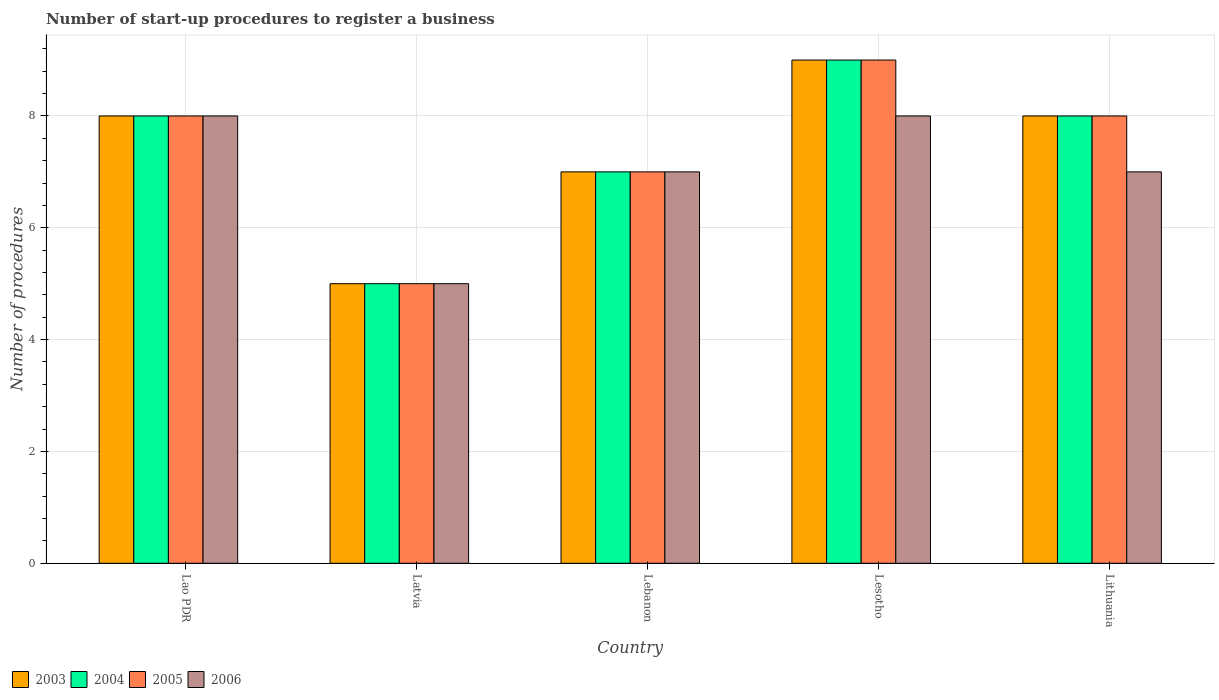How many groups of bars are there?
Offer a very short reply. 5. Are the number of bars on each tick of the X-axis equal?
Offer a terse response. Yes. How many bars are there on the 2nd tick from the left?
Give a very brief answer. 4. How many bars are there on the 4th tick from the right?
Make the answer very short. 4. What is the label of the 1st group of bars from the left?
Give a very brief answer. Lao PDR. In how many cases, is the number of bars for a given country not equal to the number of legend labels?
Make the answer very short. 0. Across all countries, what is the maximum number of procedures required to register a business in 2006?
Provide a succinct answer. 8. In which country was the number of procedures required to register a business in 2003 maximum?
Offer a terse response. Lesotho. In which country was the number of procedures required to register a business in 2004 minimum?
Ensure brevity in your answer.  Latvia. What is the difference between the number of procedures required to register a business in 2005 in Lebanon and that in Lesotho?
Make the answer very short. -2. What is the difference between the number of procedures required to register a business in 2003 in Lao PDR and the number of procedures required to register a business in 2004 in Lebanon?
Give a very brief answer. 1. In how many countries, is the number of procedures required to register a business in 2003 greater than 6?
Keep it short and to the point. 4. What is the ratio of the number of procedures required to register a business in 2006 in Lao PDR to that in Lithuania?
Offer a very short reply. 1.14. What is the difference between the highest and the second highest number of procedures required to register a business in 2003?
Give a very brief answer. -1. In how many countries, is the number of procedures required to register a business in 2005 greater than the average number of procedures required to register a business in 2005 taken over all countries?
Keep it short and to the point. 3. Is the sum of the number of procedures required to register a business in 2003 in Lao PDR and Latvia greater than the maximum number of procedures required to register a business in 2004 across all countries?
Give a very brief answer. Yes. Is it the case that in every country, the sum of the number of procedures required to register a business in 2004 and number of procedures required to register a business in 2006 is greater than the sum of number of procedures required to register a business in 2003 and number of procedures required to register a business in 2005?
Give a very brief answer. No. What does the 3rd bar from the left in Lao PDR represents?
Your response must be concise. 2005. How many countries are there in the graph?
Give a very brief answer. 5. Are the values on the major ticks of Y-axis written in scientific E-notation?
Offer a very short reply. No. Does the graph contain any zero values?
Offer a very short reply. No. How many legend labels are there?
Your response must be concise. 4. How are the legend labels stacked?
Keep it short and to the point. Horizontal. What is the title of the graph?
Offer a terse response. Number of start-up procedures to register a business. What is the label or title of the X-axis?
Your answer should be compact. Country. What is the label or title of the Y-axis?
Keep it short and to the point. Number of procedures. What is the Number of procedures in 2003 in Lao PDR?
Offer a terse response. 8. What is the Number of procedures in 2003 in Latvia?
Provide a short and direct response. 5. What is the Number of procedures of 2005 in Latvia?
Provide a succinct answer. 5. What is the Number of procedures in 2005 in Lebanon?
Your response must be concise. 7. What is the Number of procedures in 2006 in Lebanon?
Provide a short and direct response. 7. What is the Number of procedures of 2003 in Lesotho?
Offer a terse response. 9. What is the Number of procedures of 2004 in Lesotho?
Keep it short and to the point. 9. What is the Number of procedures in 2006 in Lesotho?
Offer a very short reply. 8. What is the Number of procedures of 2005 in Lithuania?
Provide a succinct answer. 8. What is the Number of procedures in 2006 in Lithuania?
Provide a short and direct response. 7. Across all countries, what is the maximum Number of procedures in 2003?
Your answer should be very brief. 9. Across all countries, what is the maximum Number of procedures in 2004?
Your response must be concise. 9. Across all countries, what is the maximum Number of procedures in 2006?
Provide a succinct answer. 8. Across all countries, what is the minimum Number of procedures in 2003?
Give a very brief answer. 5. What is the total Number of procedures in 2003 in the graph?
Your response must be concise. 37. What is the total Number of procedures of 2004 in the graph?
Offer a terse response. 37. What is the total Number of procedures in 2006 in the graph?
Give a very brief answer. 35. What is the difference between the Number of procedures of 2003 in Lao PDR and that in Latvia?
Your response must be concise. 3. What is the difference between the Number of procedures in 2004 in Lao PDR and that in Latvia?
Provide a succinct answer. 3. What is the difference between the Number of procedures in 2003 in Lao PDR and that in Lebanon?
Make the answer very short. 1. What is the difference between the Number of procedures in 2005 in Lao PDR and that in Lebanon?
Your answer should be compact. 1. What is the difference between the Number of procedures in 2006 in Lao PDR and that in Lebanon?
Your response must be concise. 1. What is the difference between the Number of procedures in 2004 in Lao PDR and that in Lesotho?
Your answer should be compact. -1. What is the difference between the Number of procedures in 2005 in Lao PDR and that in Lesotho?
Offer a terse response. -1. What is the difference between the Number of procedures of 2006 in Lao PDR and that in Lesotho?
Offer a terse response. 0. What is the difference between the Number of procedures in 2005 in Lao PDR and that in Lithuania?
Provide a succinct answer. 0. What is the difference between the Number of procedures in 2006 in Lao PDR and that in Lithuania?
Give a very brief answer. 1. What is the difference between the Number of procedures of 2003 in Latvia and that in Lebanon?
Offer a very short reply. -2. What is the difference between the Number of procedures in 2005 in Latvia and that in Lebanon?
Your answer should be very brief. -2. What is the difference between the Number of procedures in 2006 in Latvia and that in Lebanon?
Provide a succinct answer. -2. What is the difference between the Number of procedures of 2003 in Latvia and that in Lesotho?
Offer a terse response. -4. What is the difference between the Number of procedures in 2006 in Latvia and that in Lesotho?
Your answer should be compact. -3. What is the difference between the Number of procedures in 2004 in Latvia and that in Lithuania?
Keep it short and to the point. -3. What is the difference between the Number of procedures in 2005 in Latvia and that in Lithuania?
Offer a terse response. -3. What is the difference between the Number of procedures of 2006 in Latvia and that in Lithuania?
Ensure brevity in your answer.  -2. What is the difference between the Number of procedures in 2005 in Lebanon and that in Lesotho?
Keep it short and to the point. -2. What is the difference between the Number of procedures in 2006 in Lebanon and that in Lesotho?
Make the answer very short. -1. What is the difference between the Number of procedures in 2003 in Lebanon and that in Lithuania?
Your answer should be compact. -1. What is the difference between the Number of procedures of 2005 in Lebanon and that in Lithuania?
Your answer should be compact. -1. What is the difference between the Number of procedures of 2006 in Lebanon and that in Lithuania?
Offer a terse response. 0. What is the difference between the Number of procedures of 2003 in Lesotho and that in Lithuania?
Offer a very short reply. 1. What is the difference between the Number of procedures in 2006 in Lesotho and that in Lithuania?
Give a very brief answer. 1. What is the difference between the Number of procedures of 2003 in Lao PDR and the Number of procedures of 2005 in Latvia?
Give a very brief answer. 3. What is the difference between the Number of procedures in 2003 in Lao PDR and the Number of procedures in 2006 in Latvia?
Offer a terse response. 3. What is the difference between the Number of procedures of 2004 in Lao PDR and the Number of procedures of 2006 in Latvia?
Offer a terse response. 3. What is the difference between the Number of procedures in 2003 in Lao PDR and the Number of procedures in 2005 in Lebanon?
Give a very brief answer. 1. What is the difference between the Number of procedures in 2004 in Lao PDR and the Number of procedures in 2006 in Lebanon?
Give a very brief answer. 1. What is the difference between the Number of procedures of 2003 in Lao PDR and the Number of procedures of 2004 in Lesotho?
Make the answer very short. -1. What is the difference between the Number of procedures of 2003 in Lao PDR and the Number of procedures of 2006 in Lesotho?
Make the answer very short. 0. What is the difference between the Number of procedures in 2003 in Lao PDR and the Number of procedures in 2004 in Lithuania?
Provide a short and direct response. 0. What is the difference between the Number of procedures of 2003 in Lao PDR and the Number of procedures of 2006 in Lithuania?
Keep it short and to the point. 1. What is the difference between the Number of procedures in 2005 in Lao PDR and the Number of procedures in 2006 in Lithuania?
Offer a terse response. 1. What is the difference between the Number of procedures in 2003 in Latvia and the Number of procedures in 2004 in Lebanon?
Your answer should be very brief. -2. What is the difference between the Number of procedures in 2003 in Latvia and the Number of procedures in 2005 in Lebanon?
Provide a short and direct response. -2. What is the difference between the Number of procedures in 2003 in Latvia and the Number of procedures in 2006 in Lebanon?
Offer a terse response. -2. What is the difference between the Number of procedures of 2004 in Latvia and the Number of procedures of 2006 in Lebanon?
Make the answer very short. -2. What is the difference between the Number of procedures in 2005 in Latvia and the Number of procedures in 2006 in Lebanon?
Keep it short and to the point. -2. What is the difference between the Number of procedures in 2003 in Latvia and the Number of procedures in 2006 in Lesotho?
Ensure brevity in your answer.  -3. What is the difference between the Number of procedures of 2004 in Latvia and the Number of procedures of 2006 in Lesotho?
Ensure brevity in your answer.  -3. What is the difference between the Number of procedures of 2003 in Latvia and the Number of procedures of 2005 in Lithuania?
Give a very brief answer. -3. What is the difference between the Number of procedures in 2004 in Latvia and the Number of procedures in 2005 in Lithuania?
Offer a terse response. -3. What is the difference between the Number of procedures in 2003 in Lebanon and the Number of procedures in 2005 in Lesotho?
Ensure brevity in your answer.  -2. What is the difference between the Number of procedures of 2003 in Lebanon and the Number of procedures of 2006 in Lesotho?
Your answer should be compact. -1. What is the difference between the Number of procedures in 2004 in Lebanon and the Number of procedures in 2006 in Lesotho?
Provide a succinct answer. -1. What is the difference between the Number of procedures of 2005 in Lebanon and the Number of procedures of 2006 in Lesotho?
Your response must be concise. -1. What is the difference between the Number of procedures in 2003 in Lebanon and the Number of procedures in 2004 in Lithuania?
Offer a terse response. -1. What is the difference between the Number of procedures of 2004 in Lebanon and the Number of procedures of 2005 in Lithuania?
Ensure brevity in your answer.  -1. What is the difference between the Number of procedures in 2004 in Lebanon and the Number of procedures in 2006 in Lithuania?
Provide a short and direct response. 0. What is the difference between the Number of procedures in 2004 in Lesotho and the Number of procedures in 2005 in Lithuania?
Offer a terse response. 1. What is the average Number of procedures of 2004 per country?
Offer a very short reply. 7.4. What is the average Number of procedures of 2006 per country?
Your answer should be compact. 7. What is the difference between the Number of procedures of 2003 and Number of procedures of 2004 in Lao PDR?
Your answer should be compact. 0. What is the difference between the Number of procedures of 2003 and Number of procedures of 2005 in Lao PDR?
Your answer should be compact. 0. What is the difference between the Number of procedures of 2003 and Number of procedures of 2004 in Latvia?
Provide a short and direct response. 0. What is the difference between the Number of procedures of 2003 and Number of procedures of 2006 in Latvia?
Your answer should be compact. 0. What is the difference between the Number of procedures of 2004 and Number of procedures of 2006 in Latvia?
Your response must be concise. 0. What is the difference between the Number of procedures of 2005 and Number of procedures of 2006 in Latvia?
Provide a short and direct response. 0. What is the difference between the Number of procedures in 2003 and Number of procedures in 2005 in Lebanon?
Offer a terse response. 0. What is the difference between the Number of procedures of 2003 and Number of procedures of 2006 in Lebanon?
Your answer should be very brief. 0. What is the difference between the Number of procedures in 2004 and Number of procedures in 2006 in Lebanon?
Give a very brief answer. 0. What is the difference between the Number of procedures in 2003 and Number of procedures in 2006 in Lesotho?
Your answer should be very brief. 1. What is the difference between the Number of procedures in 2004 and Number of procedures in 2005 in Lesotho?
Keep it short and to the point. 0. What is the difference between the Number of procedures of 2004 and Number of procedures of 2006 in Lesotho?
Your answer should be compact. 1. What is the difference between the Number of procedures in 2005 and Number of procedures in 2006 in Lesotho?
Make the answer very short. 1. What is the difference between the Number of procedures in 2003 and Number of procedures in 2004 in Lithuania?
Offer a very short reply. 0. What is the difference between the Number of procedures of 2004 and Number of procedures of 2005 in Lithuania?
Your response must be concise. 0. What is the difference between the Number of procedures in 2004 and Number of procedures in 2006 in Lithuania?
Offer a very short reply. 1. What is the difference between the Number of procedures in 2005 and Number of procedures in 2006 in Lithuania?
Offer a very short reply. 1. What is the ratio of the Number of procedures in 2003 in Lao PDR to that in Latvia?
Ensure brevity in your answer.  1.6. What is the ratio of the Number of procedures in 2004 in Lao PDR to that in Latvia?
Offer a very short reply. 1.6. What is the ratio of the Number of procedures of 2005 in Lao PDR to that in Latvia?
Offer a terse response. 1.6. What is the ratio of the Number of procedures in 2004 in Lao PDR to that in Lebanon?
Offer a terse response. 1.14. What is the ratio of the Number of procedures of 2003 in Lao PDR to that in Lesotho?
Your answer should be compact. 0.89. What is the ratio of the Number of procedures in 2004 in Lao PDR to that in Lesotho?
Make the answer very short. 0.89. What is the ratio of the Number of procedures of 2003 in Lao PDR to that in Lithuania?
Ensure brevity in your answer.  1. What is the ratio of the Number of procedures in 2006 in Lao PDR to that in Lithuania?
Your answer should be very brief. 1.14. What is the ratio of the Number of procedures in 2004 in Latvia to that in Lebanon?
Provide a succinct answer. 0.71. What is the ratio of the Number of procedures in 2003 in Latvia to that in Lesotho?
Give a very brief answer. 0.56. What is the ratio of the Number of procedures of 2004 in Latvia to that in Lesotho?
Keep it short and to the point. 0.56. What is the ratio of the Number of procedures of 2005 in Latvia to that in Lesotho?
Offer a terse response. 0.56. What is the ratio of the Number of procedures of 2006 in Latvia to that in Lesotho?
Provide a short and direct response. 0.62. What is the ratio of the Number of procedures in 2003 in Latvia to that in Lithuania?
Your answer should be compact. 0.62. What is the ratio of the Number of procedures of 2005 in Latvia to that in Lithuania?
Ensure brevity in your answer.  0.62. What is the ratio of the Number of procedures in 2006 in Latvia to that in Lithuania?
Your answer should be compact. 0.71. What is the ratio of the Number of procedures in 2003 in Lebanon to that in Lesotho?
Ensure brevity in your answer.  0.78. What is the ratio of the Number of procedures of 2004 in Lebanon to that in Lesotho?
Offer a very short reply. 0.78. What is the ratio of the Number of procedures of 2005 in Lebanon to that in Lesotho?
Provide a succinct answer. 0.78. What is the ratio of the Number of procedures in 2006 in Lebanon to that in Lesotho?
Provide a short and direct response. 0.88. What is the ratio of the Number of procedures in 2004 in Lebanon to that in Lithuania?
Your answer should be compact. 0.88. What is the ratio of the Number of procedures of 2005 in Lebanon to that in Lithuania?
Keep it short and to the point. 0.88. What is the ratio of the Number of procedures in 2006 in Lebanon to that in Lithuania?
Make the answer very short. 1. What is the ratio of the Number of procedures of 2005 in Lesotho to that in Lithuania?
Your response must be concise. 1.12. What is the ratio of the Number of procedures of 2006 in Lesotho to that in Lithuania?
Offer a very short reply. 1.14. What is the difference between the highest and the second highest Number of procedures of 2003?
Keep it short and to the point. 1. What is the difference between the highest and the second highest Number of procedures in 2004?
Give a very brief answer. 1. What is the difference between the highest and the second highest Number of procedures in 2006?
Offer a very short reply. 0. What is the difference between the highest and the lowest Number of procedures of 2005?
Your answer should be very brief. 4. 